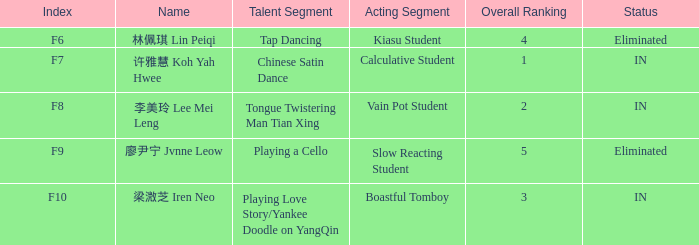For all happenings with index f10, what is the sum of the comprehensive ratings? 3.0. 